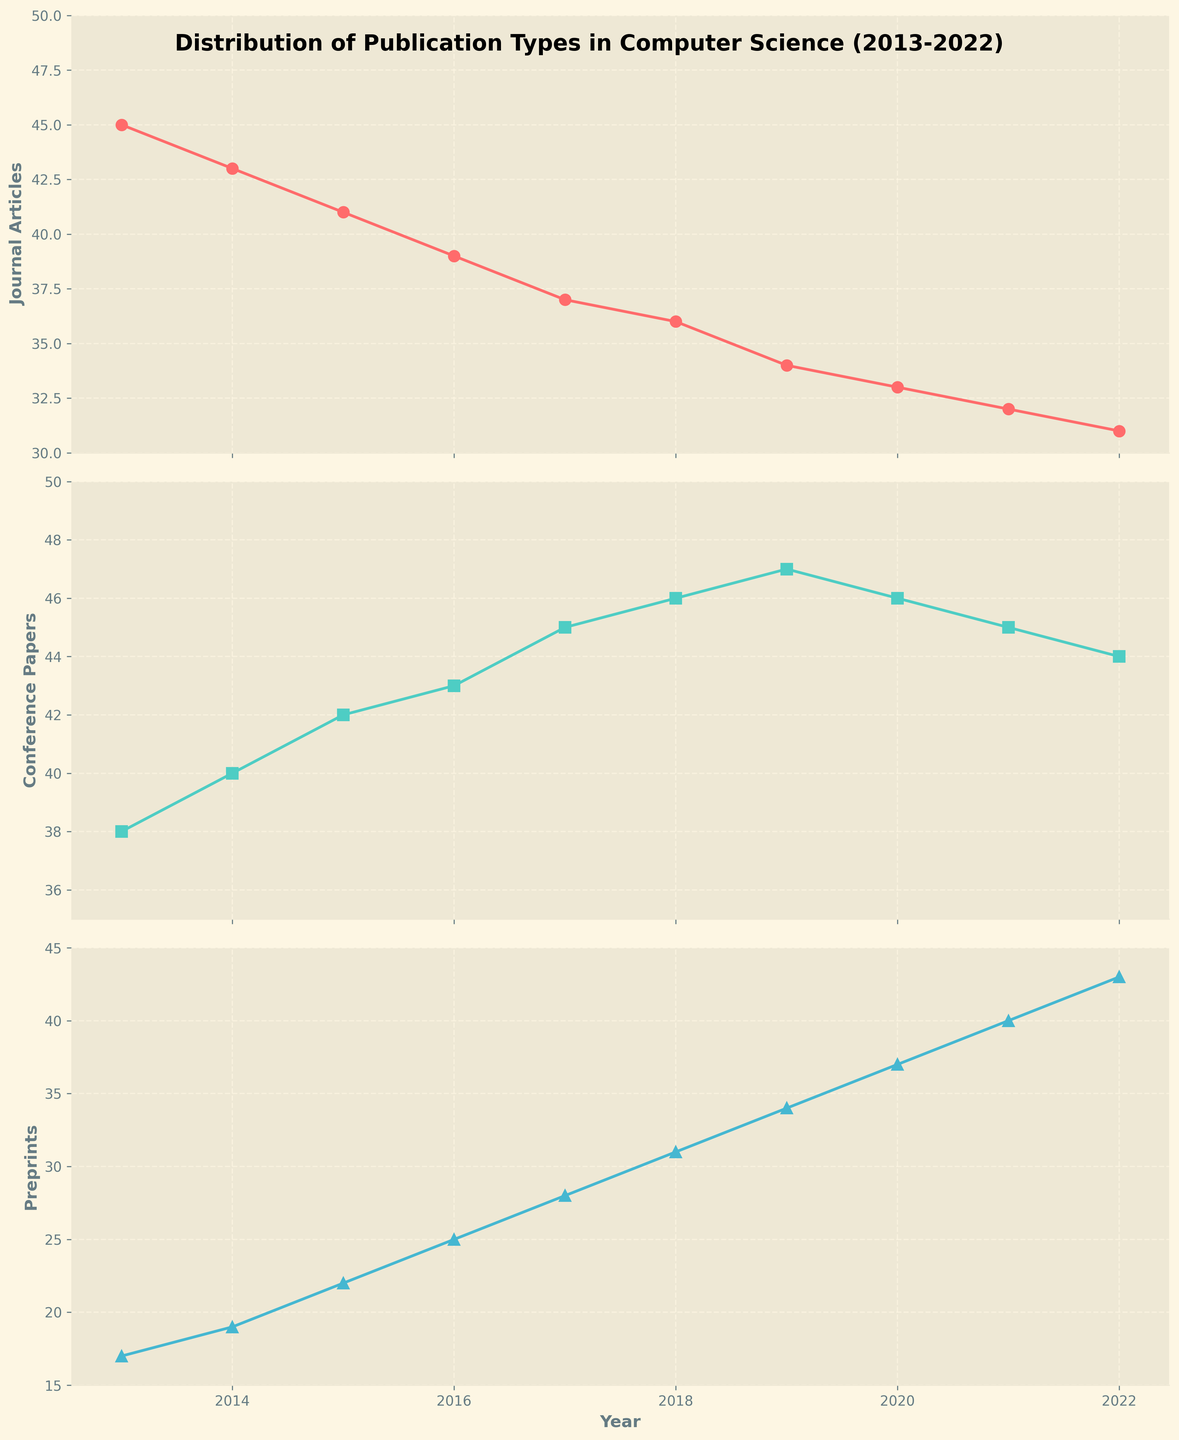What is the range of years covered in the figures? The x-axis in all subplots shows the years ranging from 2013 to 2022.
Answer: 2013-2022 How are the total numbers of journal articles changing over the years? The trend in the first subplot (Journal Articles) shows that the number of journal articles decreases from 45 in 2013 to 31 in 2022.
Answer: Decreasing Which publication type has the highest count in 2022? By comparing the data points for 2022 across all subplots, Preprints have the highest count with 43 publications.
Answer: Preprints Between which years does the steepest decline in the number of journal articles occur? Observing the plot for Journal Articles, the steepest decline occurs from 2017 (37) to 2022 (31), a difference of 6, which is the steepest compared to other consecutive years.
Answer: 2017-2022 What is the difference between the number of conference papers and preprints in 2018? From the plots, in 2018, there are 46 Conference Papers and 31 Preprints, making the difference 46 - 31 = 15.
Answer: 15 What's the overall trend observed in the number of preprints over the decade? The subplot for Preprints shows a consistent increase from 17 in 2013 to 43 in 2022.
Answer: Increasing During which years did Conference Papers exceed 45? By looking at the subplot of Conference Papers, the count exceeds 45 from 2017 to 2020.
Answer: 2017-2020 In the year 2020, which type of publication had the least number of publications? In 2020, the number of publications for Journal Articles is 33, which is the least among Conference Papers (46) and Preprints (37).
Answer: Journal Articles On average, what is the number of journal articles published per year? Sum the number of journal articles for each year: 45 + 43 + 41 + 39 + 37 + 36 + 34 + 33 + 32 + 31 = 371. Divide by 10 years: 371/10 = 37.1.
Answer: 37.1 Compare the year 2015: which type of publication was more prevalent? In 2015, the numbers are: Journal Articles (41), Conference Papers (42), and Preprints (22). Hence, Conference Papers were more prevalent.
Answer: Conference Papers 